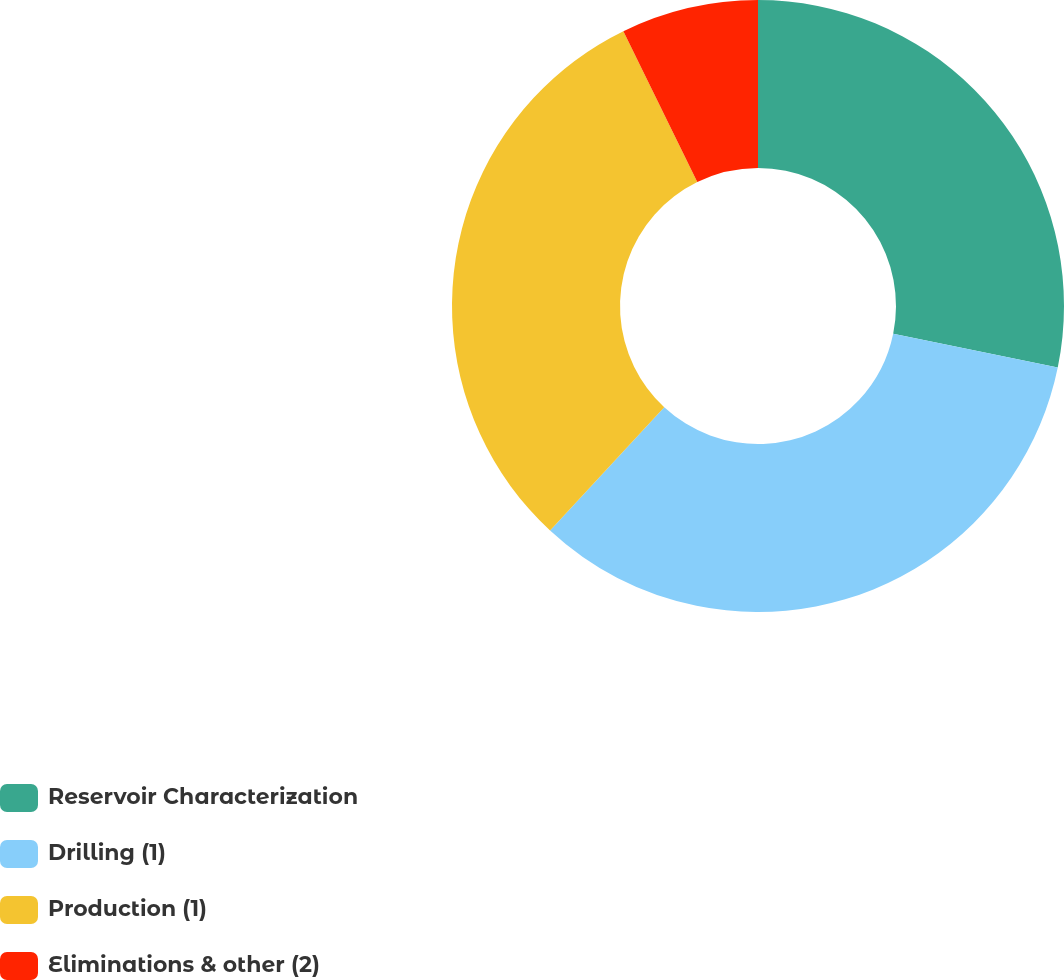<chart> <loc_0><loc_0><loc_500><loc_500><pie_chart><fcel>Reservoir Characterization<fcel>Drilling (1)<fcel>Production (1)<fcel>Eliminations & other (2)<nl><fcel>28.22%<fcel>33.67%<fcel>30.86%<fcel>7.25%<nl></chart> 